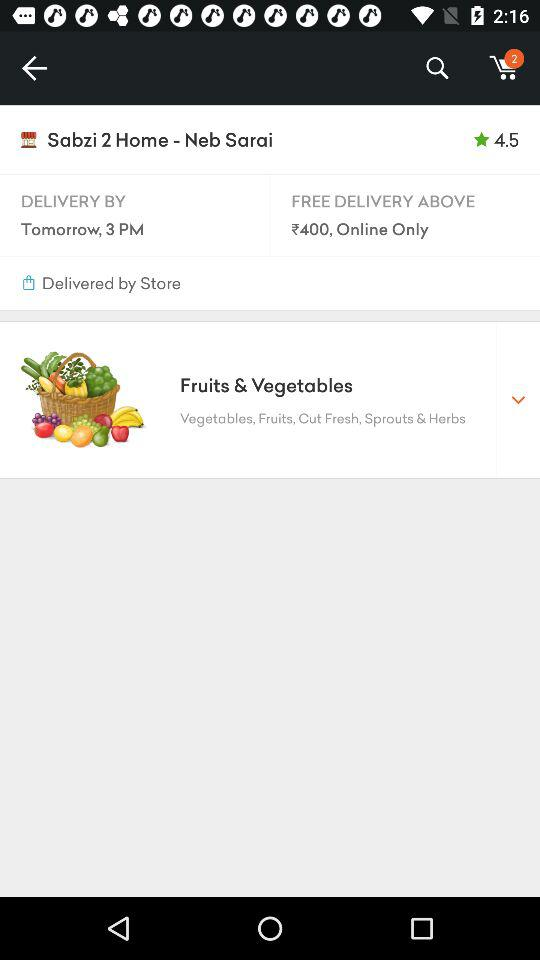How many items are in the shopping cart?
Answer the question using a single word or phrase. 2 